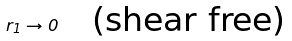<formula> <loc_0><loc_0><loc_500><loc_500>r _ { 1 } \to 0 \quad \text {(shear free)}</formula> 